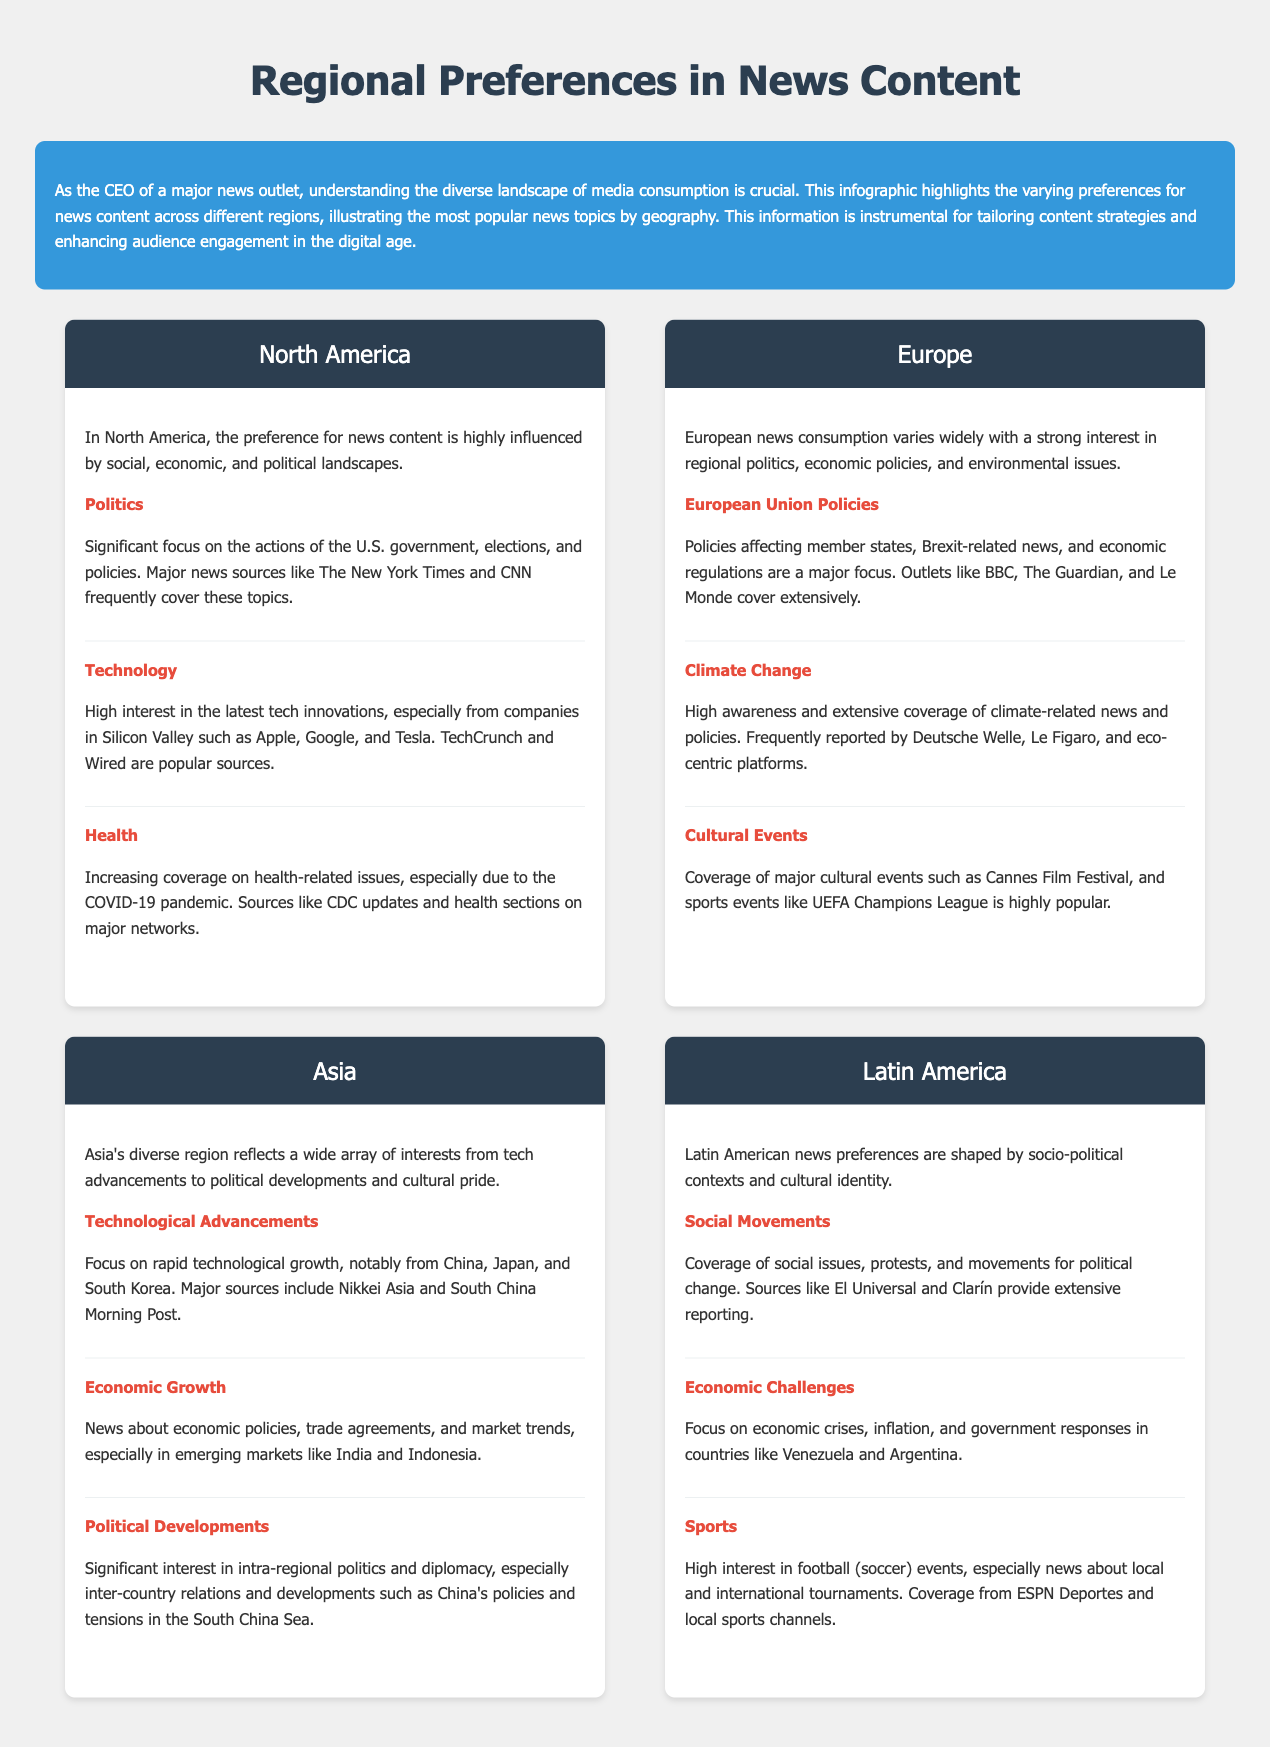what is the most popular news topic in North America? The most popular news topic in North America is Politics, which is highly influenced by social, economic, and political landscapes.
Answer: Politics which source covers European Union policies extensively? Outlets like BBC, The Guardian, and Le Monde cover extensively European Union policies affecting member states.
Answer: BBC, The Guardian, Le Monde what is a significant topic of interest in Asia? A significant topic of interest in Asia is Technological Advancements, focusing on growth notably from China, Japan, and South Korea.
Answer: Technological Advancements which news outlet is popular for health coverage in North America? Popular sources for health coverage in North America include CDC updates and health sections on major networks.
Answer: CDC updates what type of events are highly covered in Europe? Coverage of major cultural events such as the Cannes Film Festival and sports events like UEFA Champions League is highly popular in Europe.
Answer: Cultural Events what is a key issue faced by Latin America? A key issue faced by Latin America is Economic Challenges, focusing on crises and inflation in countries like Venezuela and Argentina.
Answer: Economic Challenges which region emphasizes climate change in its news consumption? Europe has a high awareness and extensive coverage of climate-related news and policies.
Answer: Europe what primary source is associated with technological advancements in Asia? Major sources include Nikkei Asia and South China Morning Post, focusing on technological advancements from the region.
Answer: Nikkei Asia, South China Morning Post 